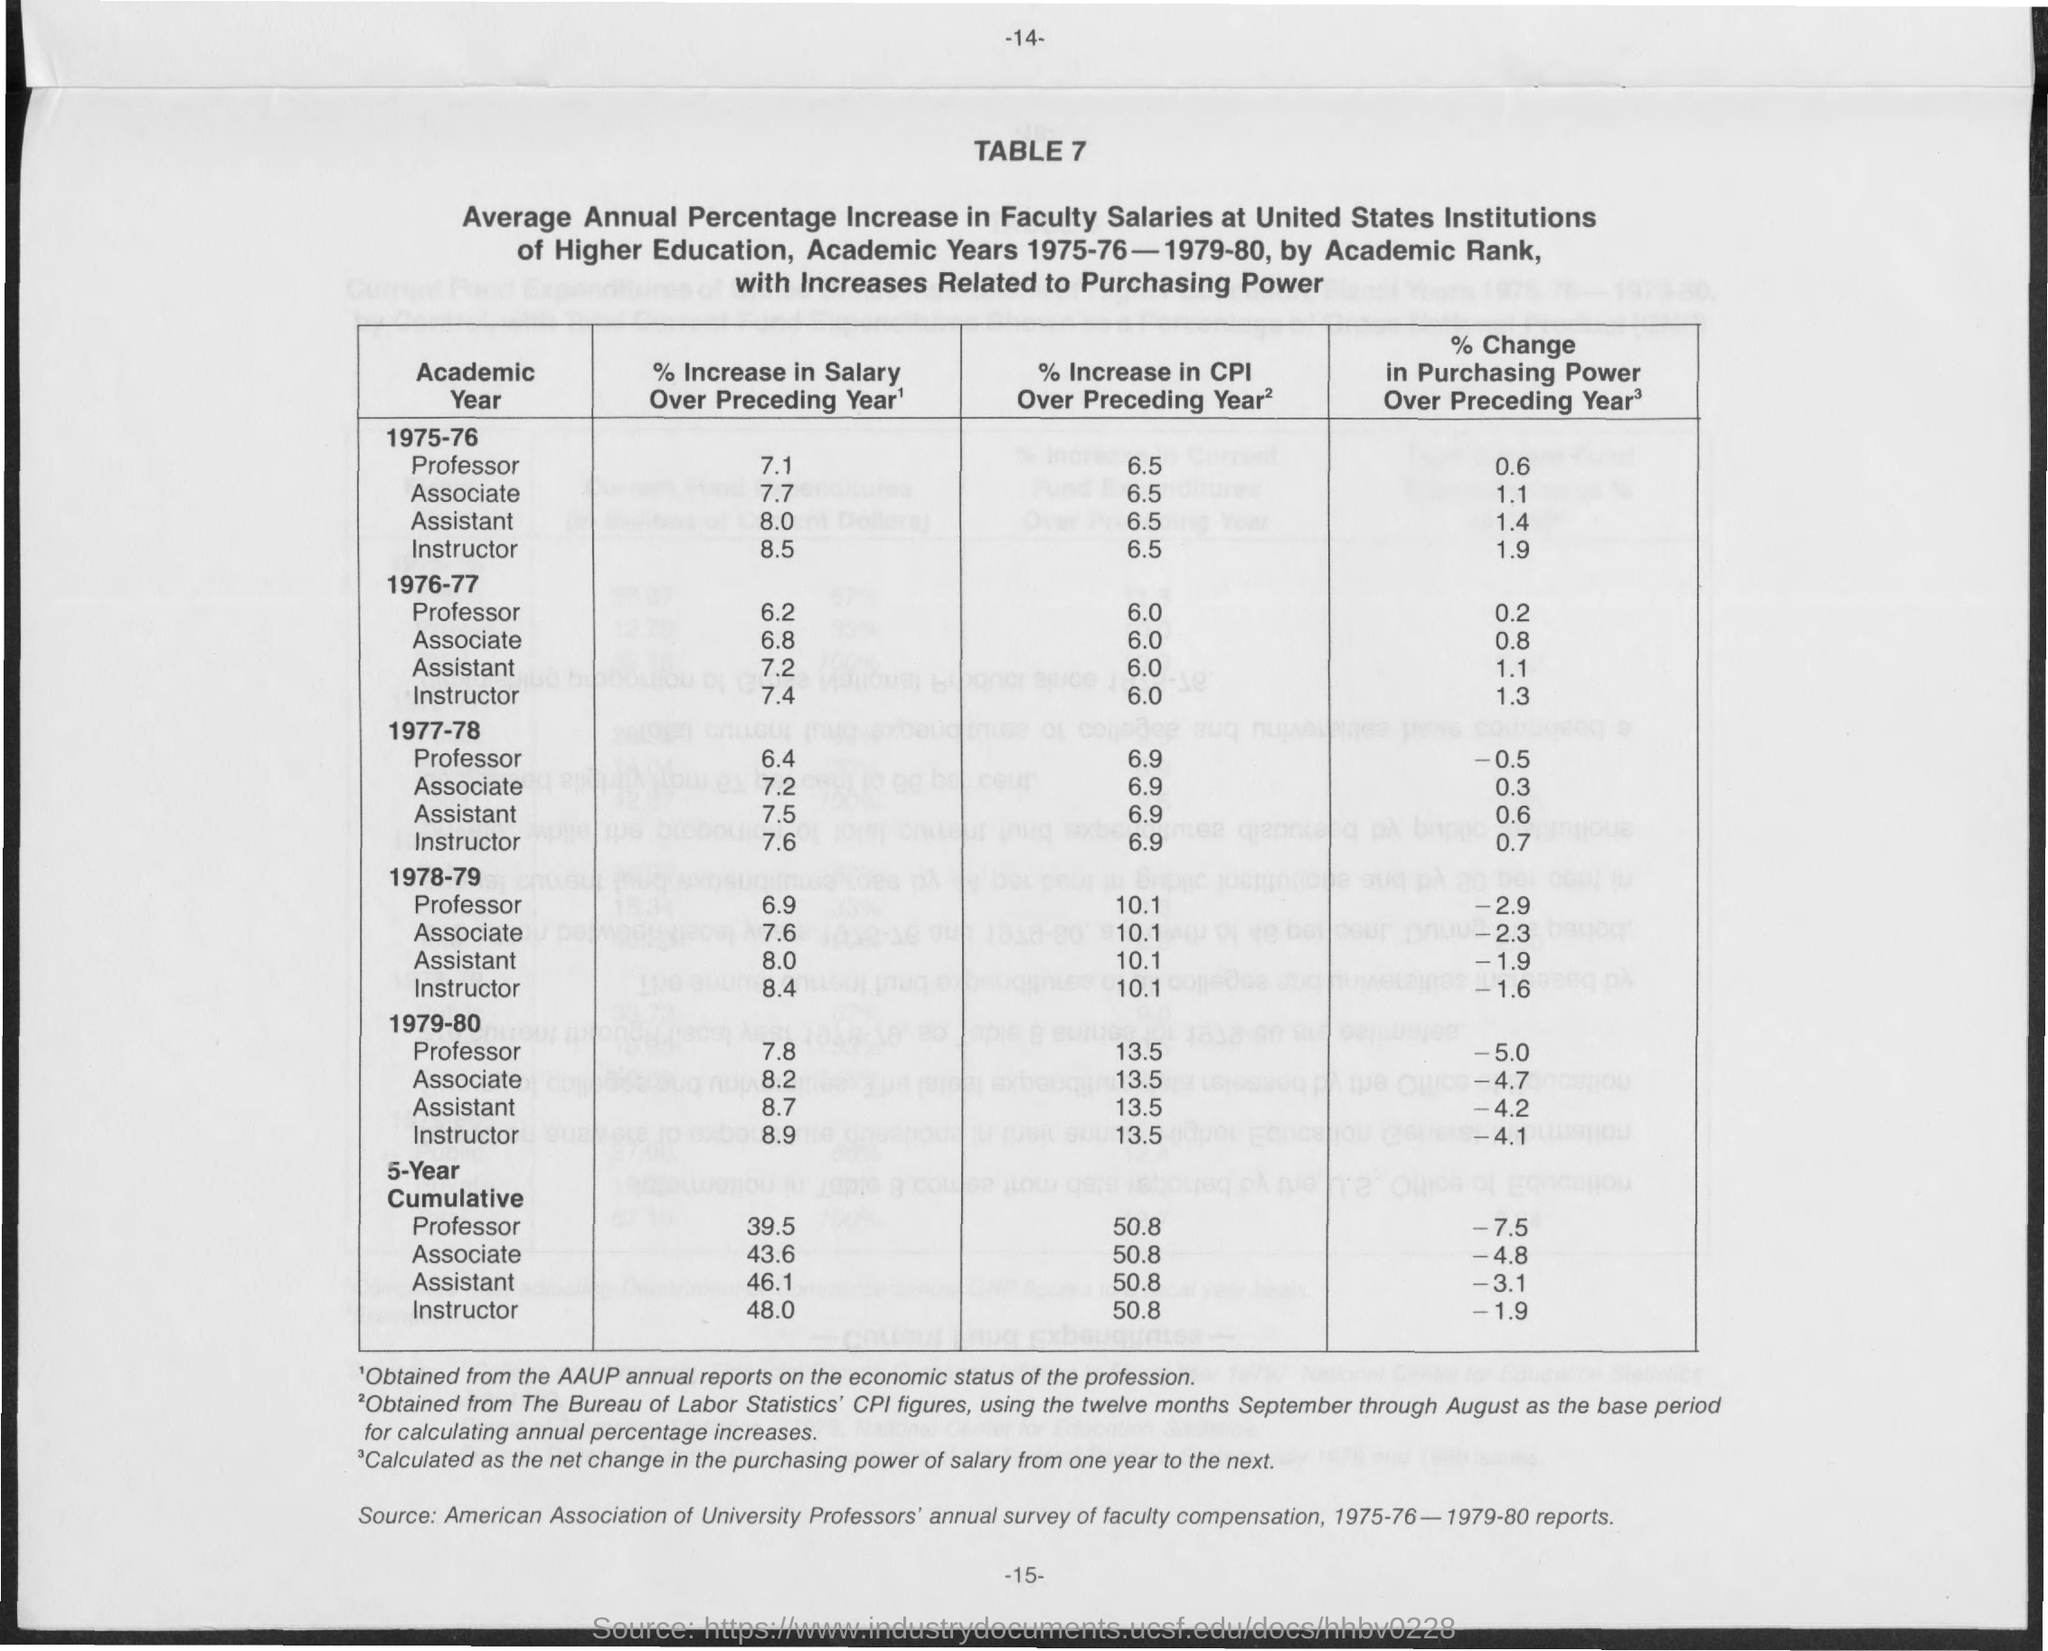What is the Page Number seen at the top?
Offer a terse response. 14. What is the % increase in salary over preceding year for professor in the year 1975-76?
Your answer should be very brief. 7.1. What is the % increase in salary over preceding year for assistant in the year 1975-76?
Offer a terse response. 8.0. 